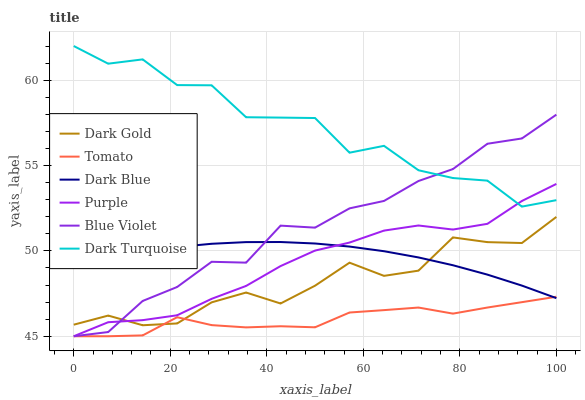Does Tomato have the minimum area under the curve?
Answer yes or no. Yes. Does Dark Turquoise have the maximum area under the curve?
Answer yes or no. Yes. Does Dark Gold have the minimum area under the curve?
Answer yes or no. No. Does Dark Gold have the maximum area under the curve?
Answer yes or no. No. Is Dark Blue the smoothest?
Answer yes or no. Yes. Is Dark Turquoise the roughest?
Answer yes or no. Yes. Is Dark Gold the smoothest?
Answer yes or no. No. Is Dark Gold the roughest?
Answer yes or no. No. Does Tomato have the lowest value?
Answer yes or no. Yes. Does Dark Gold have the lowest value?
Answer yes or no. No. Does Dark Turquoise have the highest value?
Answer yes or no. Yes. Does Dark Gold have the highest value?
Answer yes or no. No. Is Dark Blue less than Dark Turquoise?
Answer yes or no. Yes. Is Dark Turquoise greater than Tomato?
Answer yes or no. Yes. Does Purple intersect Dark Gold?
Answer yes or no. Yes. Is Purple less than Dark Gold?
Answer yes or no. No. Is Purple greater than Dark Gold?
Answer yes or no. No. Does Dark Blue intersect Dark Turquoise?
Answer yes or no. No. 